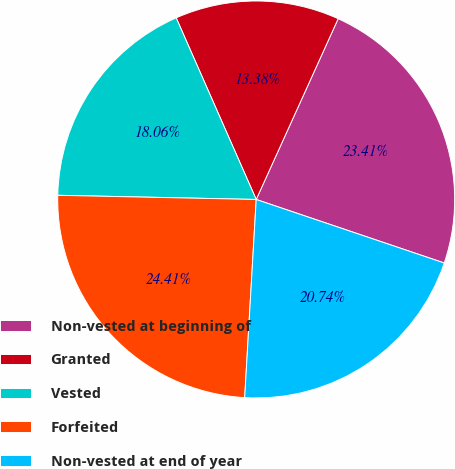Convert chart to OTSL. <chart><loc_0><loc_0><loc_500><loc_500><pie_chart><fcel>Non-vested at beginning of<fcel>Granted<fcel>Vested<fcel>Forfeited<fcel>Non-vested at end of year<nl><fcel>23.41%<fcel>13.38%<fcel>18.06%<fcel>24.41%<fcel>20.74%<nl></chart> 